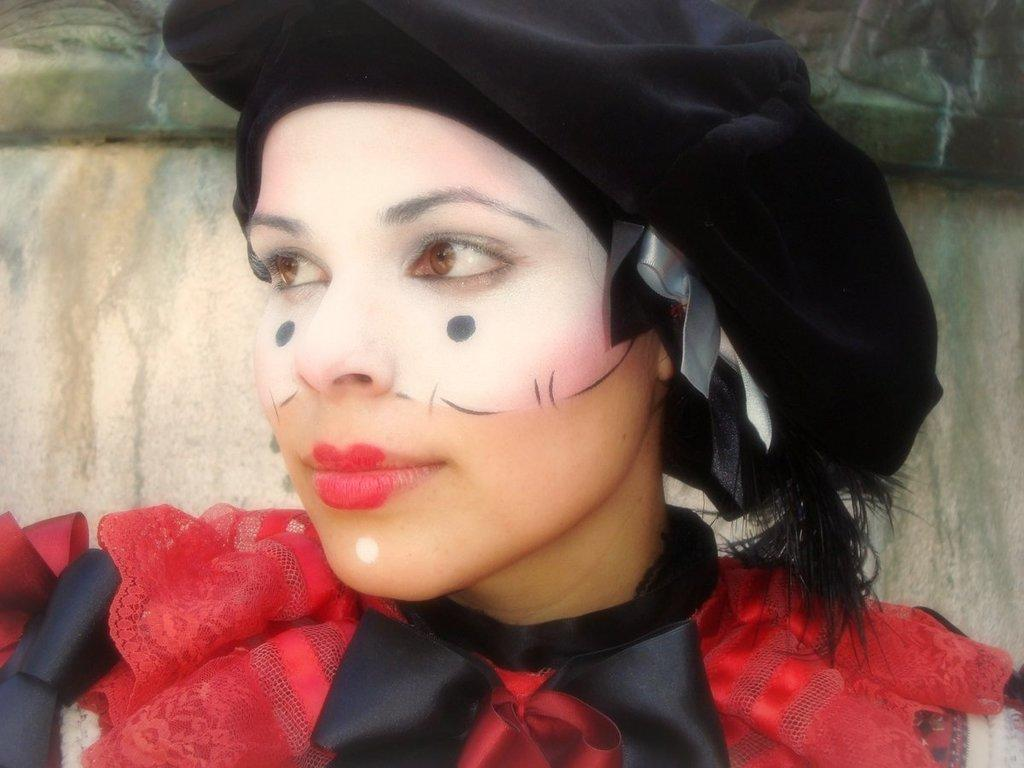Who is the main subject in the foreground of the image? There is a woman in the foreground of the image. What is the woman wearing in the image? The woman is wearing a costume in the image. What can be seen in the background of the image? There is a wall in the background of the image. Where might this image have been taken? The image may have been taken in a hall, based on the presence of a wall in the background. What type of chalk is the woman using to draw on the wall in the image? There is no chalk or drawing on the wall in the image; the woman is wearing a costume. What kind of soup is being served in the image? There is no soup present in the image. 